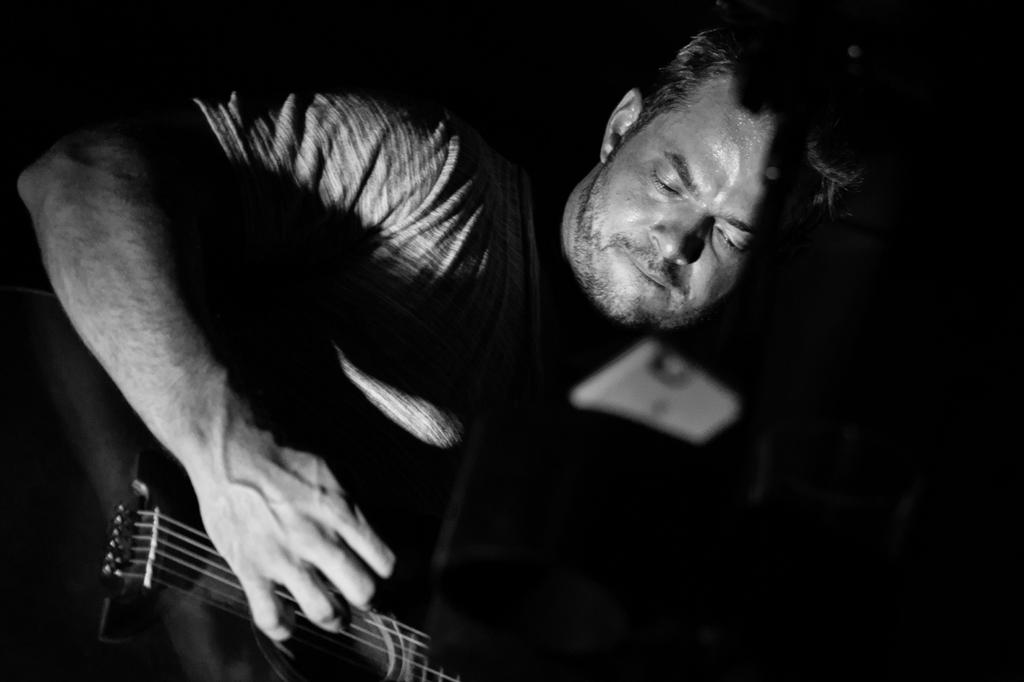What is the main subject of the image? The main subject of the image is a man. What is the man wearing in the image? The man is wearing a t-shirt in the image. What is the man's posture in the image? The man is standing in the image. What object is the man holding in the image? The man is holding a guitar in the image. What is the man doing with the guitar in the image? The man is playing the guitar in the image. What type of powder can be seen coming out of the guitar in the image? There is no powder coming out of the guitar in the image. The man is simply playing the guitar. 